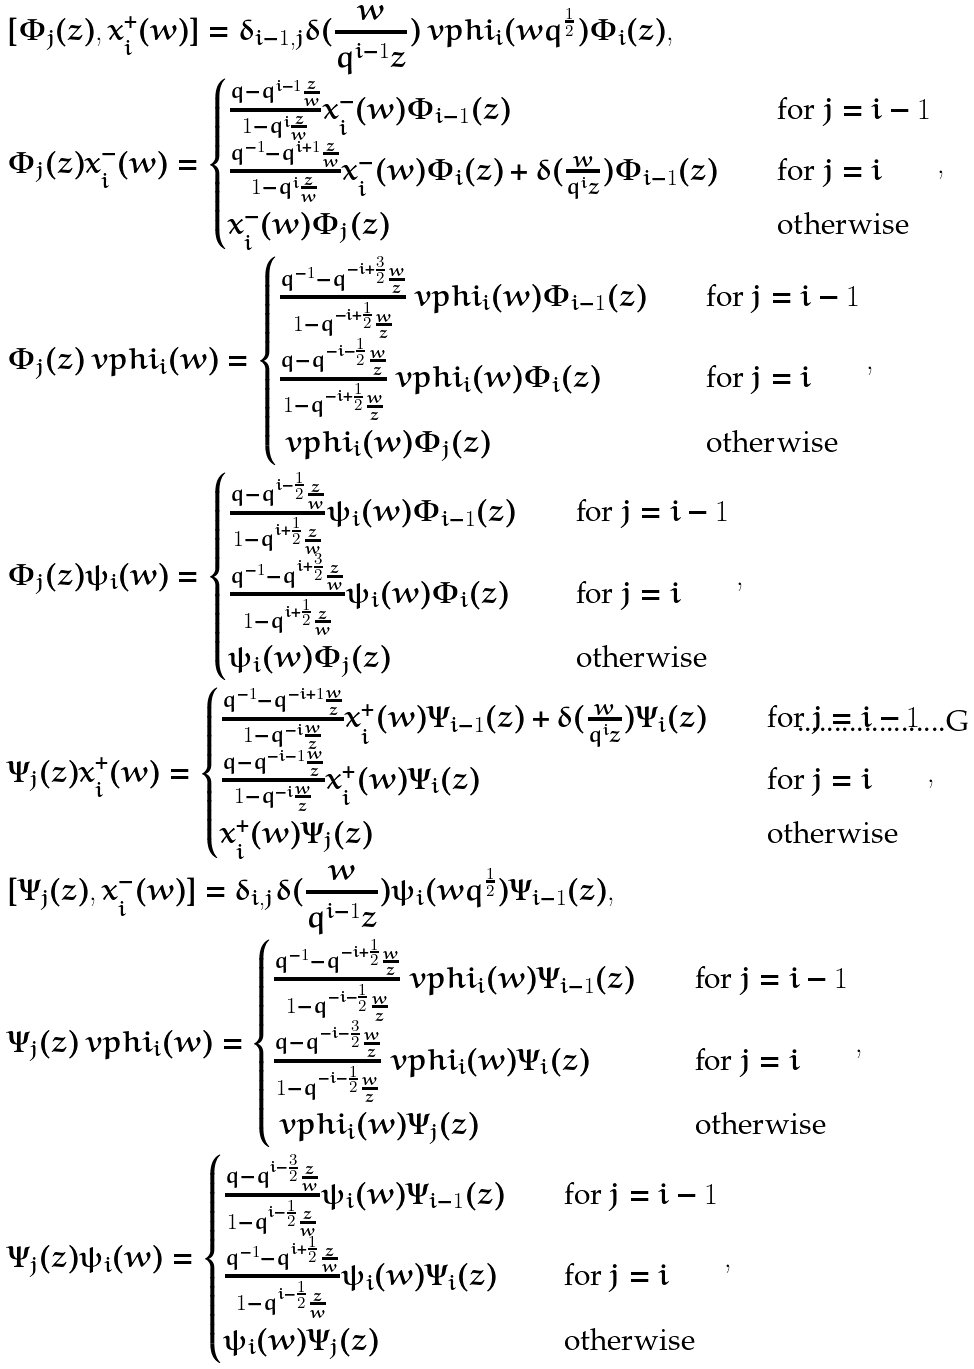<formula> <loc_0><loc_0><loc_500><loc_500>& [ \Phi _ { j } ( z ) , x _ { i } ^ { + } ( w ) ] = \delta _ { i - 1 , j } \delta ( \frac { w } { q ^ { i - 1 } z } ) \ v p h i _ { i } ( w q ^ { \frac { 1 } { 2 } } ) \Phi _ { i } ( z ) , \\ & \Phi _ { j } ( z ) x _ { i } ^ { - } ( w ) = \begin{cases} \frac { q - q ^ { i - 1 } \frac { z } { w } } { 1 - q ^ { i } \frac { z } { w } } x _ { i } ^ { - } ( w ) \Phi _ { i - 1 } ( z ) & \quad \text {for $j=i-1$} \\ \frac { q ^ { - 1 } - q ^ { i + 1 } \frac { z } { w } } { 1 - q ^ { i } \frac { z } { w } } x _ { i } ^ { - } ( w ) \Phi _ { i } ( z ) + \delta ( \frac { w } { q ^ { i } z } ) \Phi _ { i - 1 } ( z ) & \quad \text {for $j=i$} \\ x _ { i } ^ { - } ( w ) \Phi _ { j } ( z ) & \quad \text {otherwise} \end{cases} , \\ & \Phi _ { j } ( z ) \ v p h i _ { i } ( w ) = \begin{cases} \frac { q ^ { - 1 } - q ^ { - i + \frac { 3 } { 2 } } \frac { w } { z } } { 1 - q ^ { - i + \frac { 1 } { 2 } } \frac { w } { z } } \ v p h i _ { i } ( w ) \Phi _ { i - 1 } ( z ) & \quad \text {for $j=i-1$} \\ \frac { q - q ^ { - i - \frac { 1 } { 2 } } \frac { w } { z } } { 1 - q ^ { - i + \frac { 1 } { 2 } } \frac { w } { z } } \ v p h i _ { i } ( w ) \Phi _ { i } ( z ) & \quad \text {for $j=i$} \\ \ v p h i _ { i } ( w ) \Phi _ { j } ( z ) & \quad \text {otherwise} \end{cases} , \\ & \Phi _ { j } ( z ) \psi _ { i } ( w ) = \begin{cases} \frac { q - q ^ { i - \frac { 1 } { 2 } } \frac { z } { w } } { 1 - q ^ { i + \frac { 1 } { 2 } } \frac { z } { w } } \psi _ { i } ( w ) \Phi _ { i - 1 } ( z ) & \quad \text {for $j=i-1$} \\ \frac { q ^ { - 1 } - q ^ { i + \frac { 3 } { 2 } } \frac { z } { w } } { 1 - q ^ { i + \frac { 1 } { 2 } } \frac { z } { w } } \psi _ { i } ( w ) \Phi _ { i } ( z ) & \quad \text {for $j=i$} \\ \psi _ { i } ( w ) \Phi _ { j } ( z ) & \quad \text {otherwise} \end{cases} , \\ & \Psi _ { j } ( z ) x _ { i } ^ { + } ( w ) = \begin{cases} \frac { q ^ { - 1 } - q ^ { - i + 1 } \frac { w } { z } } { 1 - q ^ { - i } \frac { w } { z } } x _ { i } ^ { + } ( w ) \Psi _ { i - 1 } ( z ) + \delta ( \frac { w } { q ^ { i } z } ) \Psi _ { i } ( z ) & \quad \text {for $j=i-1$} \\ \frac { q - q ^ { - i - 1 } \frac { w } { z } } { 1 - q ^ { - i } \frac { w } { z } } x _ { i } ^ { + } ( w ) \Psi _ { i } ( z ) & \quad \text {for $j=i$} \\ x _ { i } ^ { + } ( w ) \Psi _ { j } ( z ) & \quad \text {otherwise} \end{cases} , \\ & [ \Psi _ { j } ( z ) , x _ { i } ^ { - } ( w ) ] = \delta _ { i , j } \delta ( \frac { w } { q ^ { i - 1 } z } ) \psi _ { i } ( w q ^ { \frac { 1 } { 2 } } ) \Psi _ { i - 1 } ( z ) , \\ & \Psi _ { j } ( z ) \ v p h i _ { i } ( w ) = \begin{cases} \frac { q ^ { - 1 } - q ^ { - i + \frac { 1 } { 2 } } \frac { w } { z } } { 1 - q ^ { - i - \frac { 1 } { 2 } } \frac { w } { z } } \ v p h i _ { i } ( w ) \Psi _ { i - 1 } ( z ) & \quad \text {for $j=i-1$} \\ \frac { q - q ^ { - i - \frac { 3 } { 2 } } \frac { w } { z } } { 1 - q ^ { - i - \frac { 1 } { 2 } } \frac { w } { z } } \ v p h i _ { i } ( w ) \Psi _ { i } ( z ) & \quad \text {for $j=i$} \\ \ v p h i _ { i } ( w ) \Psi _ { j } ( z ) & \quad \text {otherwise} \end{cases} , \\ & \Psi _ { j } ( z ) \psi _ { i } ( w ) = \begin{cases} \frac { q - q ^ { i - \frac { 3 } { 2 } } \frac { z } { w } } { 1 - q ^ { i - \frac { 1 } { 2 } } \frac { z } { w } } \psi _ { i } ( w ) \Psi _ { i - 1 } ( z ) & \quad \text {for $j=i-1$} \\ \frac { q ^ { - 1 } - q ^ { i + \frac { 1 } { 2 } } \frac { z } { w } } { 1 - q ^ { i - \frac { 1 } { 2 } } \frac { z } { w } } \psi _ { i } ( w ) \Psi _ { i } ( z ) & \quad \text {for $j=i$} \\ \psi _ { i } ( w ) \Psi _ { j } ( z ) & \quad \text {otherwise} \end{cases} ,</formula> 